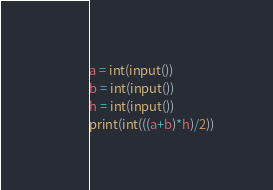<code> <loc_0><loc_0><loc_500><loc_500><_Python_>a = int(input())
b = int(input())
h = int(input())
print(int(((a+b)*h)/2))</code> 